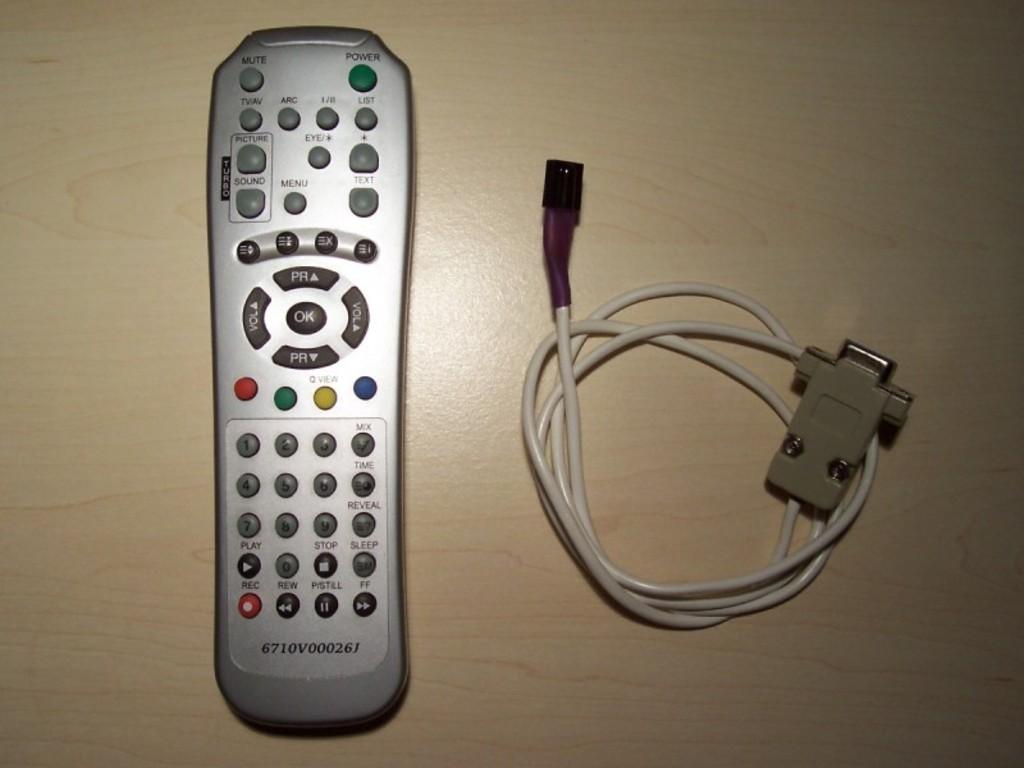What is the first number of the model number?
Ensure brevity in your answer.  6. 